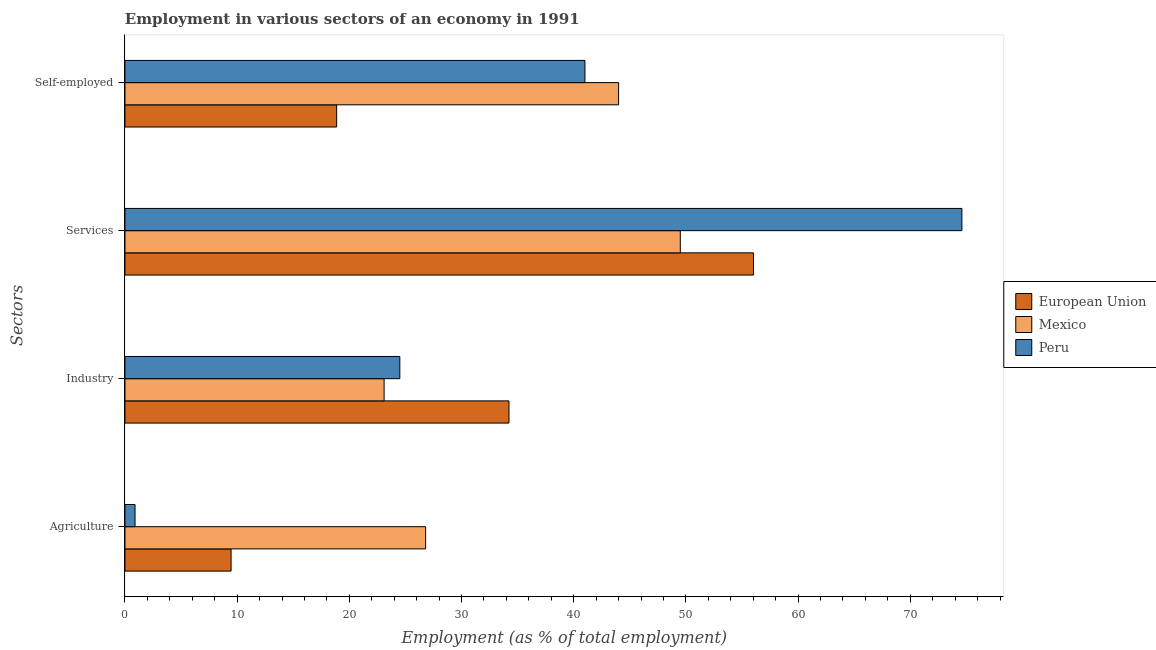How many different coloured bars are there?
Give a very brief answer. 3. Are the number of bars on each tick of the Y-axis equal?
Your answer should be very brief. Yes. How many bars are there on the 3rd tick from the top?
Provide a succinct answer. 3. What is the label of the 1st group of bars from the top?
Offer a terse response. Self-employed. What is the percentage of workers in agriculture in Peru?
Provide a short and direct response. 0.9. Across all countries, what is the maximum percentage of workers in agriculture?
Provide a succinct answer. 26.8. Across all countries, what is the minimum percentage of workers in agriculture?
Keep it short and to the point. 0.9. In which country was the percentage of self employed workers minimum?
Give a very brief answer. European Union. What is the total percentage of self employed workers in the graph?
Your answer should be compact. 103.87. What is the difference between the percentage of workers in services in European Union and that in Mexico?
Your answer should be very brief. 6.52. What is the difference between the percentage of workers in industry in Peru and the percentage of self employed workers in European Union?
Ensure brevity in your answer.  5.63. What is the average percentage of workers in agriculture per country?
Your answer should be compact. 12.39. What is the difference between the percentage of self employed workers and percentage of workers in services in Mexico?
Your answer should be compact. -5.5. What is the ratio of the percentage of self employed workers in Peru to that in Mexico?
Ensure brevity in your answer.  0.93. Is the percentage of workers in agriculture in European Union less than that in Peru?
Ensure brevity in your answer.  No. What is the difference between the highest and the second highest percentage of workers in agriculture?
Your answer should be compact. 17.34. What is the difference between the highest and the lowest percentage of workers in services?
Provide a short and direct response. 25.1. In how many countries, is the percentage of workers in industry greater than the average percentage of workers in industry taken over all countries?
Ensure brevity in your answer.  1. Is it the case that in every country, the sum of the percentage of workers in agriculture and percentage of workers in industry is greater than the percentage of workers in services?
Provide a succinct answer. No. How many bars are there?
Ensure brevity in your answer.  12. How many countries are there in the graph?
Offer a terse response. 3. Does the graph contain grids?
Your answer should be compact. No. What is the title of the graph?
Make the answer very short. Employment in various sectors of an economy in 1991. What is the label or title of the X-axis?
Give a very brief answer. Employment (as % of total employment). What is the label or title of the Y-axis?
Your answer should be very brief. Sectors. What is the Employment (as % of total employment) in European Union in Agriculture?
Offer a very short reply. 9.46. What is the Employment (as % of total employment) of Mexico in Agriculture?
Your answer should be compact. 26.8. What is the Employment (as % of total employment) in Peru in Agriculture?
Give a very brief answer. 0.9. What is the Employment (as % of total employment) in European Union in Industry?
Offer a very short reply. 34.23. What is the Employment (as % of total employment) of Mexico in Industry?
Ensure brevity in your answer.  23.1. What is the Employment (as % of total employment) in Peru in Industry?
Provide a short and direct response. 24.5. What is the Employment (as % of total employment) in European Union in Services?
Provide a short and direct response. 56.02. What is the Employment (as % of total employment) in Mexico in Services?
Give a very brief answer. 49.5. What is the Employment (as % of total employment) in Peru in Services?
Keep it short and to the point. 74.6. What is the Employment (as % of total employment) of European Union in Self-employed?
Provide a succinct answer. 18.87. What is the Employment (as % of total employment) of Peru in Self-employed?
Provide a short and direct response. 41. Across all Sectors, what is the maximum Employment (as % of total employment) of European Union?
Your answer should be compact. 56.02. Across all Sectors, what is the maximum Employment (as % of total employment) of Mexico?
Make the answer very short. 49.5. Across all Sectors, what is the maximum Employment (as % of total employment) in Peru?
Offer a terse response. 74.6. Across all Sectors, what is the minimum Employment (as % of total employment) in European Union?
Provide a short and direct response. 9.46. Across all Sectors, what is the minimum Employment (as % of total employment) in Mexico?
Offer a very short reply. 23.1. Across all Sectors, what is the minimum Employment (as % of total employment) of Peru?
Your answer should be very brief. 0.9. What is the total Employment (as % of total employment) of European Union in the graph?
Offer a very short reply. 118.58. What is the total Employment (as % of total employment) of Mexico in the graph?
Give a very brief answer. 143.4. What is the total Employment (as % of total employment) in Peru in the graph?
Keep it short and to the point. 141. What is the difference between the Employment (as % of total employment) of European Union in Agriculture and that in Industry?
Provide a succinct answer. -24.77. What is the difference between the Employment (as % of total employment) in Mexico in Agriculture and that in Industry?
Make the answer very short. 3.7. What is the difference between the Employment (as % of total employment) of Peru in Agriculture and that in Industry?
Keep it short and to the point. -23.6. What is the difference between the Employment (as % of total employment) of European Union in Agriculture and that in Services?
Provide a succinct answer. -46.56. What is the difference between the Employment (as % of total employment) of Mexico in Agriculture and that in Services?
Make the answer very short. -22.7. What is the difference between the Employment (as % of total employment) in Peru in Agriculture and that in Services?
Make the answer very short. -73.7. What is the difference between the Employment (as % of total employment) of European Union in Agriculture and that in Self-employed?
Give a very brief answer. -9.41. What is the difference between the Employment (as % of total employment) of Mexico in Agriculture and that in Self-employed?
Your answer should be compact. -17.2. What is the difference between the Employment (as % of total employment) in Peru in Agriculture and that in Self-employed?
Provide a succinct answer. -40.1. What is the difference between the Employment (as % of total employment) in European Union in Industry and that in Services?
Keep it short and to the point. -21.79. What is the difference between the Employment (as % of total employment) of Mexico in Industry and that in Services?
Offer a very short reply. -26.4. What is the difference between the Employment (as % of total employment) of Peru in Industry and that in Services?
Offer a very short reply. -50.1. What is the difference between the Employment (as % of total employment) of European Union in Industry and that in Self-employed?
Provide a short and direct response. 15.36. What is the difference between the Employment (as % of total employment) of Mexico in Industry and that in Self-employed?
Offer a very short reply. -20.9. What is the difference between the Employment (as % of total employment) of Peru in Industry and that in Self-employed?
Your response must be concise. -16.5. What is the difference between the Employment (as % of total employment) of European Union in Services and that in Self-employed?
Offer a terse response. 37.15. What is the difference between the Employment (as % of total employment) of Mexico in Services and that in Self-employed?
Give a very brief answer. 5.5. What is the difference between the Employment (as % of total employment) in Peru in Services and that in Self-employed?
Your response must be concise. 33.6. What is the difference between the Employment (as % of total employment) in European Union in Agriculture and the Employment (as % of total employment) in Mexico in Industry?
Your response must be concise. -13.64. What is the difference between the Employment (as % of total employment) of European Union in Agriculture and the Employment (as % of total employment) of Peru in Industry?
Offer a very short reply. -15.04. What is the difference between the Employment (as % of total employment) in Mexico in Agriculture and the Employment (as % of total employment) in Peru in Industry?
Provide a short and direct response. 2.3. What is the difference between the Employment (as % of total employment) in European Union in Agriculture and the Employment (as % of total employment) in Mexico in Services?
Provide a short and direct response. -40.04. What is the difference between the Employment (as % of total employment) of European Union in Agriculture and the Employment (as % of total employment) of Peru in Services?
Your answer should be very brief. -65.14. What is the difference between the Employment (as % of total employment) of Mexico in Agriculture and the Employment (as % of total employment) of Peru in Services?
Give a very brief answer. -47.8. What is the difference between the Employment (as % of total employment) of European Union in Agriculture and the Employment (as % of total employment) of Mexico in Self-employed?
Keep it short and to the point. -34.54. What is the difference between the Employment (as % of total employment) in European Union in Agriculture and the Employment (as % of total employment) in Peru in Self-employed?
Your answer should be very brief. -31.54. What is the difference between the Employment (as % of total employment) in Mexico in Agriculture and the Employment (as % of total employment) in Peru in Self-employed?
Offer a terse response. -14.2. What is the difference between the Employment (as % of total employment) of European Union in Industry and the Employment (as % of total employment) of Mexico in Services?
Offer a terse response. -15.27. What is the difference between the Employment (as % of total employment) of European Union in Industry and the Employment (as % of total employment) of Peru in Services?
Offer a very short reply. -40.37. What is the difference between the Employment (as % of total employment) of Mexico in Industry and the Employment (as % of total employment) of Peru in Services?
Give a very brief answer. -51.5. What is the difference between the Employment (as % of total employment) of European Union in Industry and the Employment (as % of total employment) of Mexico in Self-employed?
Give a very brief answer. -9.77. What is the difference between the Employment (as % of total employment) of European Union in Industry and the Employment (as % of total employment) of Peru in Self-employed?
Provide a succinct answer. -6.77. What is the difference between the Employment (as % of total employment) of Mexico in Industry and the Employment (as % of total employment) of Peru in Self-employed?
Your response must be concise. -17.9. What is the difference between the Employment (as % of total employment) in European Union in Services and the Employment (as % of total employment) in Mexico in Self-employed?
Give a very brief answer. 12.02. What is the difference between the Employment (as % of total employment) in European Union in Services and the Employment (as % of total employment) in Peru in Self-employed?
Provide a succinct answer. 15.02. What is the average Employment (as % of total employment) of European Union per Sectors?
Your answer should be compact. 29.65. What is the average Employment (as % of total employment) in Mexico per Sectors?
Provide a succinct answer. 35.85. What is the average Employment (as % of total employment) in Peru per Sectors?
Provide a short and direct response. 35.25. What is the difference between the Employment (as % of total employment) in European Union and Employment (as % of total employment) in Mexico in Agriculture?
Ensure brevity in your answer.  -17.34. What is the difference between the Employment (as % of total employment) of European Union and Employment (as % of total employment) of Peru in Agriculture?
Ensure brevity in your answer.  8.56. What is the difference between the Employment (as % of total employment) of Mexico and Employment (as % of total employment) of Peru in Agriculture?
Keep it short and to the point. 25.9. What is the difference between the Employment (as % of total employment) of European Union and Employment (as % of total employment) of Mexico in Industry?
Provide a succinct answer. 11.13. What is the difference between the Employment (as % of total employment) in European Union and Employment (as % of total employment) in Peru in Industry?
Your answer should be very brief. 9.73. What is the difference between the Employment (as % of total employment) of European Union and Employment (as % of total employment) of Mexico in Services?
Ensure brevity in your answer.  6.52. What is the difference between the Employment (as % of total employment) in European Union and Employment (as % of total employment) in Peru in Services?
Keep it short and to the point. -18.58. What is the difference between the Employment (as % of total employment) of Mexico and Employment (as % of total employment) of Peru in Services?
Your answer should be very brief. -25.1. What is the difference between the Employment (as % of total employment) in European Union and Employment (as % of total employment) in Mexico in Self-employed?
Offer a terse response. -25.13. What is the difference between the Employment (as % of total employment) of European Union and Employment (as % of total employment) of Peru in Self-employed?
Keep it short and to the point. -22.13. What is the difference between the Employment (as % of total employment) of Mexico and Employment (as % of total employment) of Peru in Self-employed?
Ensure brevity in your answer.  3. What is the ratio of the Employment (as % of total employment) of European Union in Agriculture to that in Industry?
Your response must be concise. 0.28. What is the ratio of the Employment (as % of total employment) in Mexico in Agriculture to that in Industry?
Your answer should be compact. 1.16. What is the ratio of the Employment (as % of total employment) of Peru in Agriculture to that in Industry?
Your answer should be compact. 0.04. What is the ratio of the Employment (as % of total employment) in European Union in Agriculture to that in Services?
Ensure brevity in your answer.  0.17. What is the ratio of the Employment (as % of total employment) of Mexico in Agriculture to that in Services?
Your answer should be compact. 0.54. What is the ratio of the Employment (as % of total employment) in Peru in Agriculture to that in Services?
Your answer should be compact. 0.01. What is the ratio of the Employment (as % of total employment) in European Union in Agriculture to that in Self-employed?
Offer a very short reply. 0.5. What is the ratio of the Employment (as % of total employment) of Mexico in Agriculture to that in Self-employed?
Offer a terse response. 0.61. What is the ratio of the Employment (as % of total employment) in Peru in Agriculture to that in Self-employed?
Provide a short and direct response. 0.02. What is the ratio of the Employment (as % of total employment) in European Union in Industry to that in Services?
Your answer should be very brief. 0.61. What is the ratio of the Employment (as % of total employment) in Mexico in Industry to that in Services?
Ensure brevity in your answer.  0.47. What is the ratio of the Employment (as % of total employment) of Peru in Industry to that in Services?
Provide a short and direct response. 0.33. What is the ratio of the Employment (as % of total employment) of European Union in Industry to that in Self-employed?
Your response must be concise. 1.81. What is the ratio of the Employment (as % of total employment) of Mexico in Industry to that in Self-employed?
Your response must be concise. 0.53. What is the ratio of the Employment (as % of total employment) in Peru in Industry to that in Self-employed?
Provide a succinct answer. 0.6. What is the ratio of the Employment (as % of total employment) of European Union in Services to that in Self-employed?
Ensure brevity in your answer.  2.97. What is the ratio of the Employment (as % of total employment) of Mexico in Services to that in Self-employed?
Provide a short and direct response. 1.12. What is the ratio of the Employment (as % of total employment) of Peru in Services to that in Self-employed?
Provide a short and direct response. 1.82. What is the difference between the highest and the second highest Employment (as % of total employment) of European Union?
Your response must be concise. 21.79. What is the difference between the highest and the second highest Employment (as % of total employment) of Mexico?
Your answer should be compact. 5.5. What is the difference between the highest and the second highest Employment (as % of total employment) in Peru?
Your response must be concise. 33.6. What is the difference between the highest and the lowest Employment (as % of total employment) of European Union?
Offer a very short reply. 46.56. What is the difference between the highest and the lowest Employment (as % of total employment) in Mexico?
Give a very brief answer. 26.4. What is the difference between the highest and the lowest Employment (as % of total employment) of Peru?
Make the answer very short. 73.7. 